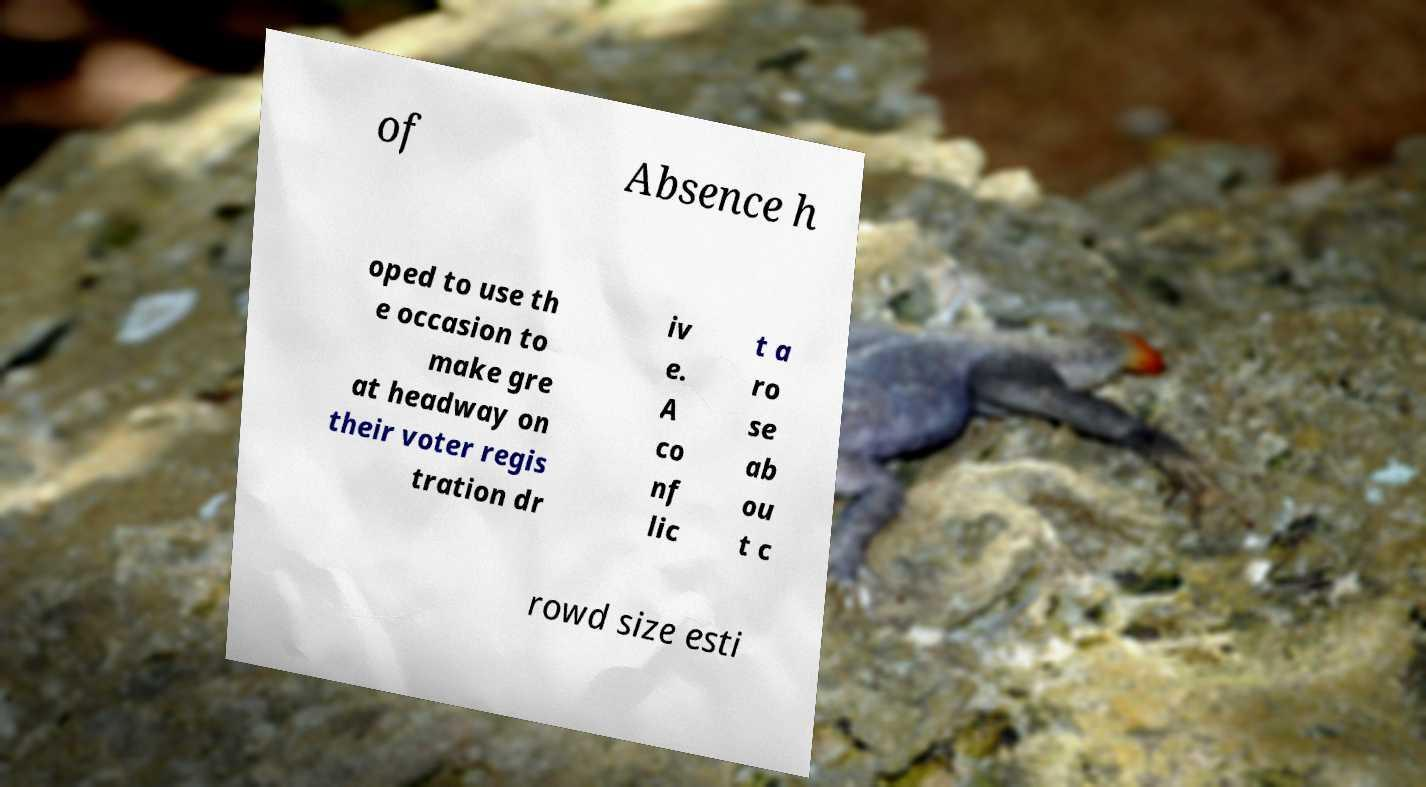For documentation purposes, I need the text within this image transcribed. Could you provide that? of Absence h oped to use th e occasion to make gre at headway on their voter regis tration dr iv e. A co nf lic t a ro se ab ou t c rowd size esti 